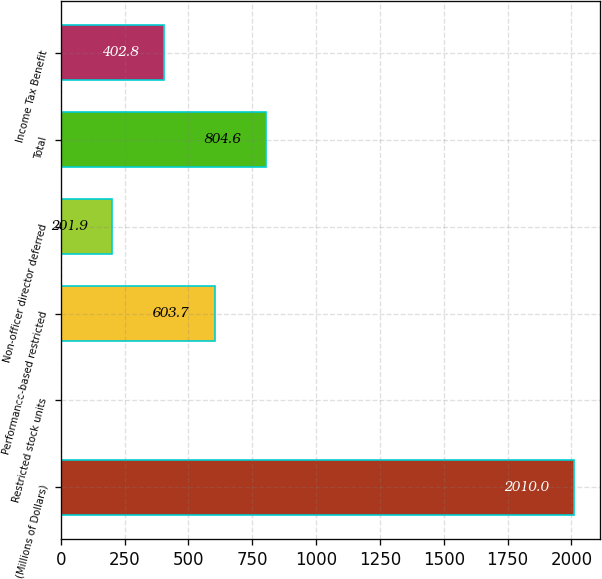<chart> <loc_0><loc_0><loc_500><loc_500><bar_chart><fcel>(Millions of Dollars)<fcel>Restricted stock units<fcel>Performance-based restricted<fcel>Non-officer director deferred<fcel>Total<fcel>Income Tax Benefit<nl><fcel>2010<fcel>1<fcel>603.7<fcel>201.9<fcel>804.6<fcel>402.8<nl></chart> 